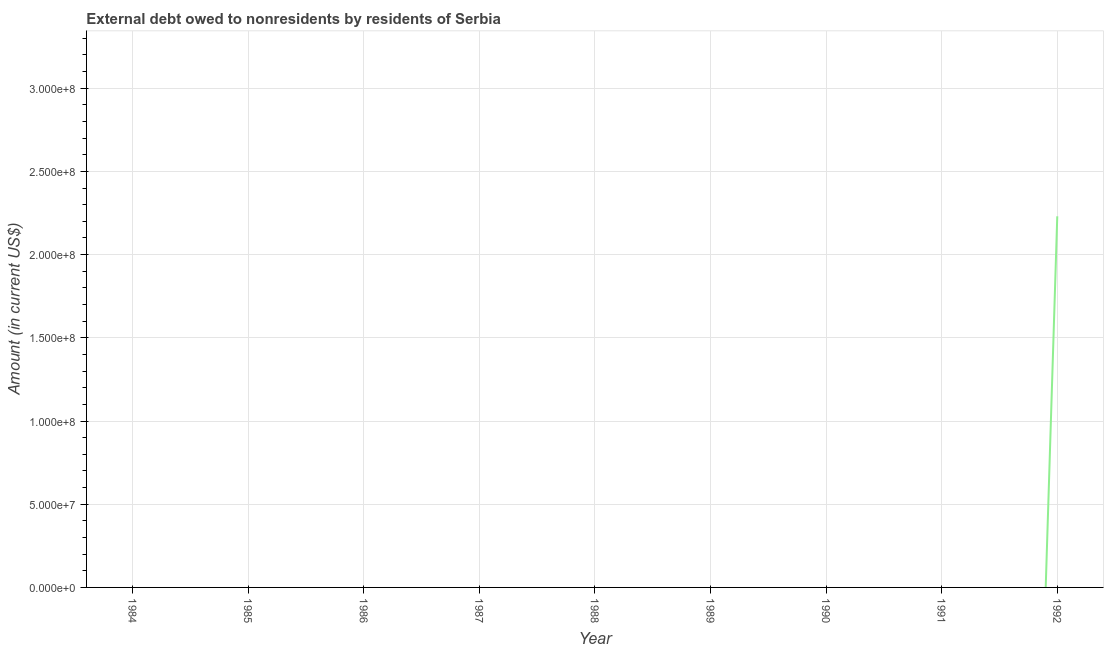What is the debt in 1988?
Provide a short and direct response. 0. Across all years, what is the maximum debt?
Your answer should be compact. 2.23e+08. In which year was the debt maximum?
Your answer should be compact. 1992. What is the sum of the debt?
Your answer should be very brief. 2.23e+08. What is the average debt per year?
Provide a short and direct response. 2.48e+07. What is the difference between the highest and the lowest debt?
Ensure brevity in your answer.  2.23e+08. What is the difference between two consecutive major ticks on the Y-axis?
Make the answer very short. 5.00e+07. Are the values on the major ticks of Y-axis written in scientific E-notation?
Offer a very short reply. Yes. What is the title of the graph?
Keep it short and to the point. External debt owed to nonresidents by residents of Serbia. What is the Amount (in current US$) in 1984?
Your answer should be compact. 0. What is the Amount (in current US$) in 1985?
Your answer should be very brief. 0. What is the Amount (in current US$) in 1986?
Provide a short and direct response. 0. What is the Amount (in current US$) in 1988?
Keep it short and to the point. 0. What is the Amount (in current US$) of 1991?
Give a very brief answer. 0. What is the Amount (in current US$) of 1992?
Provide a succinct answer. 2.23e+08. 